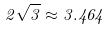<formula> <loc_0><loc_0><loc_500><loc_500>2 \sqrt { 3 } \approx 3 . 4 6 4</formula> 